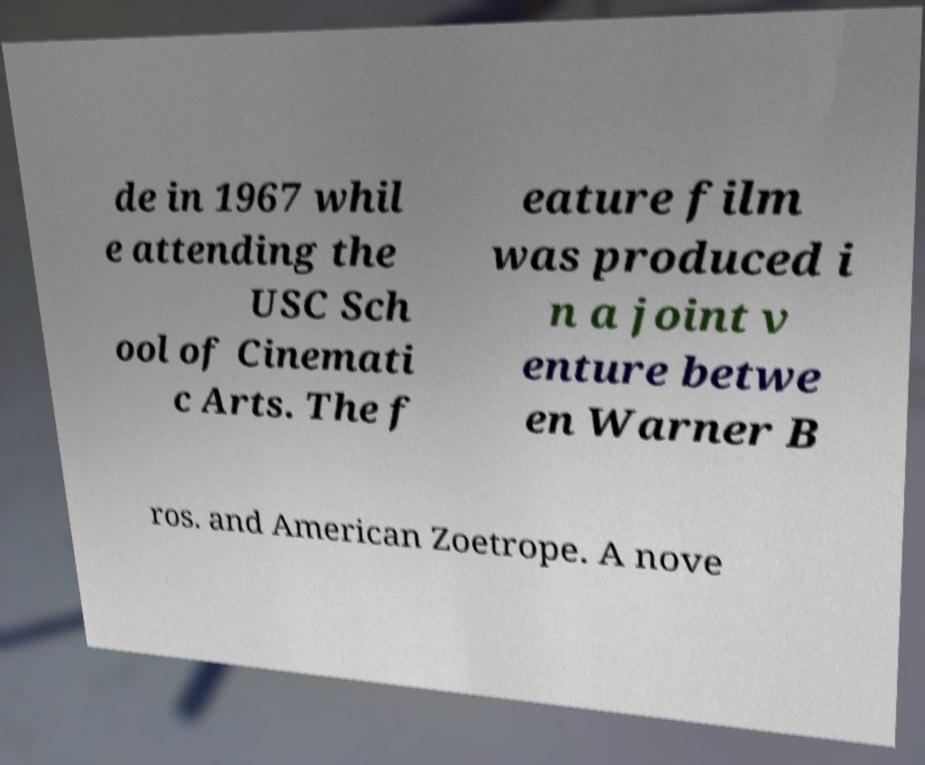I need the written content from this picture converted into text. Can you do that? de in 1967 whil e attending the USC Sch ool of Cinemati c Arts. The f eature film was produced i n a joint v enture betwe en Warner B ros. and American Zoetrope. A nove 